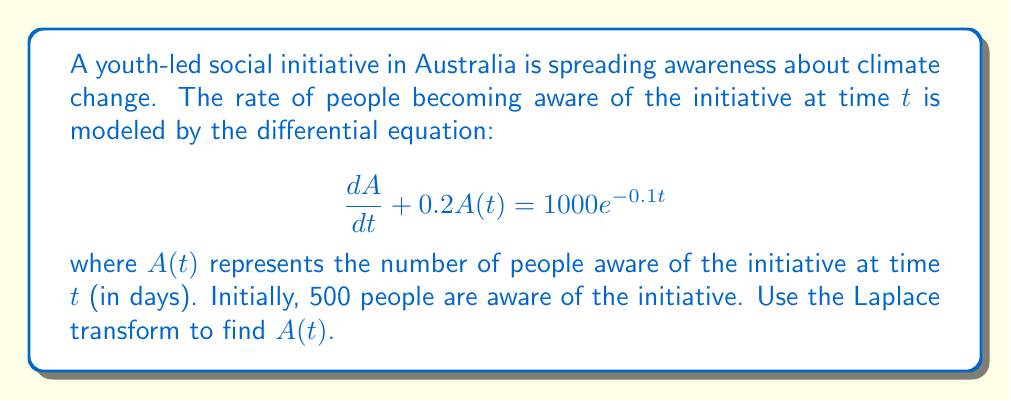Show me your answer to this math problem. Let's solve this problem step by step using the Laplace transform:

1) First, we take the Laplace transform of both sides of the equation:

   $\mathcal{L}\{\frac{dA}{dt} + 0.2A(t)\} = \mathcal{L}\{1000e^{-0.1t}\}$

2) Using the linearity property and the Laplace transform of the derivative:

   $[s\mathcal{L}\{A(t)\} - A(0)] + 0.2\mathcal{L}\{A(t)\} = \frac{1000}{s+0.1}$

3) Let $\mathcal{L}\{A(t)\} = F(s)$. We're given that $A(0) = 500$. Substituting:

   $sF(s) - 500 + 0.2F(s) = \frac{1000}{s+0.1}$

4) Simplify:

   $(s + 0.2)F(s) = \frac{1000}{s+0.1} + 500$

5) Solve for $F(s)$:

   $F(s) = \frac{1000}{(s+0.1)(s+0.2)} + \frac{500}{s+0.2}$

6) Use partial fraction decomposition:

   $F(s) = \frac{10000}{s+0.1} - \frac{10000}{s+0.2} + \frac{500}{s+0.2}$
   
   $= \frac{10000}{s+0.1} - \frac{9500}{s+0.2}$

7) Now, we can take the inverse Laplace transform:

   $A(t) = 10000e^{-0.1t} - 9500e^{-0.2t}$

This is the solution to the differential equation that models the spread of the youth-led initiative.
Answer: $A(t) = 10000e^{-0.1t} - 9500e^{-0.2t}$ 